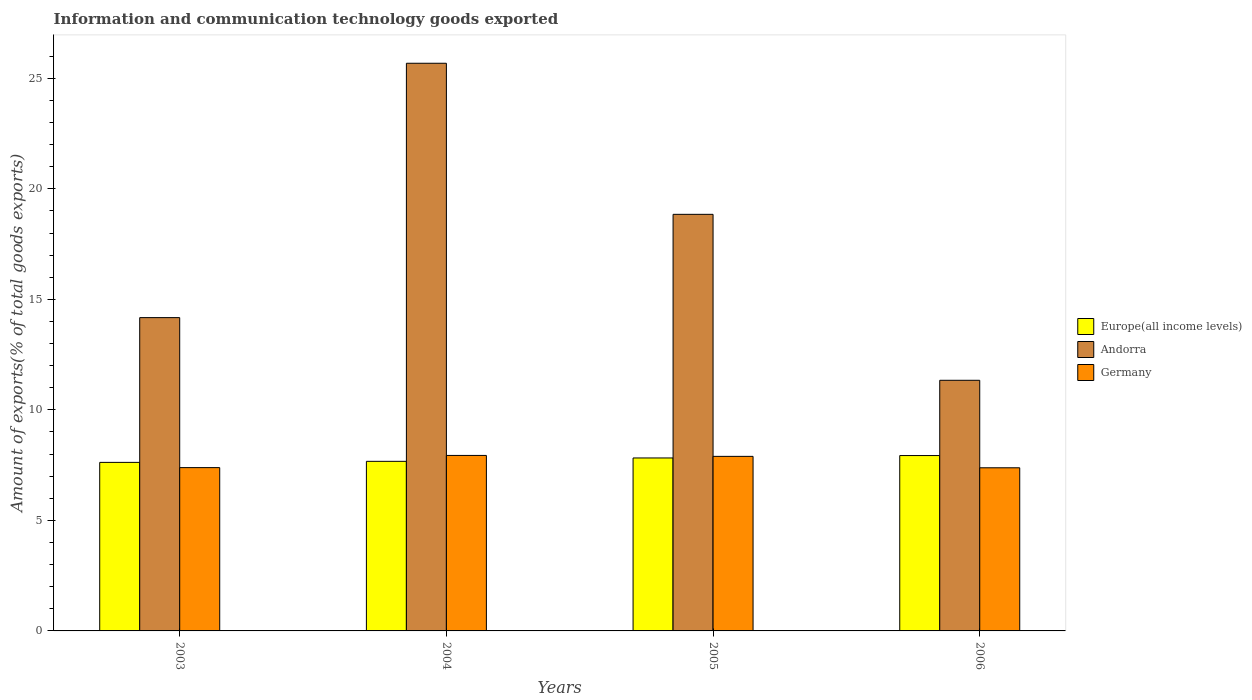How many different coloured bars are there?
Your response must be concise. 3. Are the number of bars on each tick of the X-axis equal?
Your answer should be very brief. Yes. How many bars are there on the 1st tick from the right?
Your answer should be compact. 3. What is the label of the 2nd group of bars from the left?
Keep it short and to the point. 2004. In how many cases, is the number of bars for a given year not equal to the number of legend labels?
Provide a short and direct response. 0. What is the amount of goods exported in Germany in 2006?
Ensure brevity in your answer.  7.38. Across all years, what is the maximum amount of goods exported in Europe(all income levels)?
Make the answer very short. 7.93. Across all years, what is the minimum amount of goods exported in Andorra?
Your answer should be very brief. 11.34. In which year was the amount of goods exported in Andorra minimum?
Ensure brevity in your answer.  2006. What is the total amount of goods exported in Germany in the graph?
Offer a terse response. 30.61. What is the difference between the amount of goods exported in Germany in 2003 and that in 2006?
Your answer should be very brief. 0.01. What is the difference between the amount of goods exported in Europe(all income levels) in 2003 and the amount of goods exported in Germany in 2005?
Offer a very short reply. -0.27. What is the average amount of goods exported in Germany per year?
Your answer should be very brief. 7.65. In the year 2005, what is the difference between the amount of goods exported in Andorra and amount of goods exported in Europe(all income levels)?
Your response must be concise. 11.02. What is the ratio of the amount of goods exported in Germany in 2003 to that in 2006?
Keep it short and to the point. 1. What is the difference between the highest and the second highest amount of goods exported in Europe(all income levels)?
Make the answer very short. 0.11. What is the difference between the highest and the lowest amount of goods exported in Germany?
Your response must be concise. 0.56. Is the sum of the amount of goods exported in Germany in 2003 and 2004 greater than the maximum amount of goods exported in Europe(all income levels) across all years?
Offer a terse response. Yes. What does the 2nd bar from the left in 2006 represents?
Provide a short and direct response. Andorra. What does the 2nd bar from the right in 2006 represents?
Your response must be concise. Andorra. Is it the case that in every year, the sum of the amount of goods exported in Andorra and amount of goods exported in Germany is greater than the amount of goods exported in Europe(all income levels)?
Ensure brevity in your answer.  Yes. How many bars are there?
Your answer should be very brief. 12. Are all the bars in the graph horizontal?
Provide a short and direct response. No. Are the values on the major ticks of Y-axis written in scientific E-notation?
Ensure brevity in your answer.  No. How many legend labels are there?
Offer a very short reply. 3. What is the title of the graph?
Make the answer very short. Information and communication technology goods exported. What is the label or title of the Y-axis?
Provide a succinct answer. Amount of exports(% of total goods exports). What is the Amount of exports(% of total goods exports) of Europe(all income levels) in 2003?
Offer a terse response. 7.63. What is the Amount of exports(% of total goods exports) in Andorra in 2003?
Give a very brief answer. 14.17. What is the Amount of exports(% of total goods exports) in Germany in 2003?
Make the answer very short. 7.39. What is the Amount of exports(% of total goods exports) of Europe(all income levels) in 2004?
Offer a terse response. 7.67. What is the Amount of exports(% of total goods exports) of Andorra in 2004?
Give a very brief answer. 25.68. What is the Amount of exports(% of total goods exports) of Germany in 2004?
Your answer should be compact. 7.94. What is the Amount of exports(% of total goods exports) in Europe(all income levels) in 2005?
Your answer should be very brief. 7.83. What is the Amount of exports(% of total goods exports) in Andorra in 2005?
Keep it short and to the point. 18.85. What is the Amount of exports(% of total goods exports) in Germany in 2005?
Provide a short and direct response. 7.9. What is the Amount of exports(% of total goods exports) in Europe(all income levels) in 2006?
Your answer should be very brief. 7.93. What is the Amount of exports(% of total goods exports) in Andorra in 2006?
Offer a very short reply. 11.34. What is the Amount of exports(% of total goods exports) in Germany in 2006?
Provide a succinct answer. 7.38. Across all years, what is the maximum Amount of exports(% of total goods exports) in Europe(all income levels)?
Keep it short and to the point. 7.93. Across all years, what is the maximum Amount of exports(% of total goods exports) of Andorra?
Make the answer very short. 25.68. Across all years, what is the maximum Amount of exports(% of total goods exports) in Germany?
Provide a short and direct response. 7.94. Across all years, what is the minimum Amount of exports(% of total goods exports) of Europe(all income levels)?
Provide a short and direct response. 7.63. Across all years, what is the minimum Amount of exports(% of total goods exports) in Andorra?
Give a very brief answer. 11.34. Across all years, what is the minimum Amount of exports(% of total goods exports) of Germany?
Provide a succinct answer. 7.38. What is the total Amount of exports(% of total goods exports) of Europe(all income levels) in the graph?
Provide a succinct answer. 31.06. What is the total Amount of exports(% of total goods exports) of Andorra in the graph?
Provide a short and direct response. 70.04. What is the total Amount of exports(% of total goods exports) in Germany in the graph?
Provide a short and direct response. 30.61. What is the difference between the Amount of exports(% of total goods exports) of Europe(all income levels) in 2003 and that in 2004?
Provide a short and direct response. -0.05. What is the difference between the Amount of exports(% of total goods exports) of Andorra in 2003 and that in 2004?
Provide a succinct answer. -11.51. What is the difference between the Amount of exports(% of total goods exports) of Germany in 2003 and that in 2004?
Offer a very short reply. -0.55. What is the difference between the Amount of exports(% of total goods exports) in Andorra in 2003 and that in 2005?
Give a very brief answer. -4.67. What is the difference between the Amount of exports(% of total goods exports) in Germany in 2003 and that in 2005?
Keep it short and to the point. -0.51. What is the difference between the Amount of exports(% of total goods exports) in Europe(all income levels) in 2003 and that in 2006?
Provide a succinct answer. -0.31. What is the difference between the Amount of exports(% of total goods exports) in Andorra in 2003 and that in 2006?
Give a very brief answer. 2.84. What is the difference between the Amount of exports(% of total goods exports) of Germany in 2003 and that in 2006?
Give a very brief answer. 0.01. What is the difference between the Amount of exports(% of total goods exports) of Europe(all income levels) in 2004 and that in 2005?
Offer a very short reply. -0.15. What is the difference between the Amount of exports(% of total goods exports) in Andorra in 2004 and that in 2005?
Offer a very short reply. 6.83. What is the difference between the Amount of exports(% of total goods exports) of Germany in 2004 and that in 2005?
Your response must be concise. 0.04. What is the difference between the Amount of exports(% of total goods exports) of Europe(all income levels) in 2004 and that in 2006?
Offer a terse response. -0.26. What is the difference between the Amount of exports(% of total goods exports) in Andorra in 2004 and that in 2006?
Provide a succinct answer. 14.34. What is the difference between the Amount of exports(% of total goods exports) of Germany in 2004 and that in 2006?
Your response must be concise. 0.56. What is the difference between the Amount of exports(% of total goods exports) in Europe(all income levels) in 2005 and that in 2006?
Your answer should be very brief. -0.11. What is the difference between the Amount of exports(% of total goods exports) in Andorra in 2005 and that in 2006?
Your answer should be very brief. 7.51. What is the difference between the Amount of exports(% of total goods exports) of Germany in 2005 and that in 2006?
Provide a short and direct response. 0.52. What is the difference between the Amount of exports(% of total goods exports) in Europe(all income levels) in 2003 and the Amount of exports(% of total goods exports) in Andorra in 2004?
Your answer should be very brief. -18.06. What is the difference between the Amount of exports(% of total goods exports) in Europe(all income levels) in 2003 and the Amount of exports(% of total goods exports) in Germany in 2004?
Keep it short and to the point. -0.31. What is the difference between the Amount of exports(% of total goods exports) in Andorra in 2003 and the Amount of exports(% of total goods exports) in Germany in 2004?
Ensure brevity in your answer.  6.23. What is the difference between the Amount of exports(% of total goods exports) in Europe(all income levels) in 2003 and the Amount of exports(% of total goods exports) in Andorra in 2005?
Offer a very short reply. -11.22. What is the difference between the Amount of exports(% of total goods exports) in Europe(all income levels) in 2003 and the Amount of exports(% of total goods exports) in Germany in 2005?
Provide a short and direct response. -0.27. What is the difference between the Amount of exports(% of total goods exports) of Andorra in 2003 and the Amount of exports(% of total goods exports) of Germany in 2005?
Offer a terse response. 6.28. What is the difference between the Amount of exports(% of total goods exports) in Europe(all income levels) in 2003 and the Amount of exports(% of total goods exports) in Andorra in 2006?
Your answer should be compact. -3.71. What is the difference between the Amount of exports(% of total goods exports) of Europe(all income levels) in 2003 and the Amount of exports(% of total goods exports) of Germany in 2006?
Ensure brevity in your answer.  0.24. What is the difference between the Amount of exports(% of total goods exports) in Andorra in 2003 and the Amount of exports(% of total goods exports) in Germany in 2006?
Your answer should be compact. 6.79. What is the difference between the Amount of exports(% of total goods exports) of Europe(all income levels) in 2004 and the Amount of exports(% of total goods exports) of Andorra in 2005?
Make the answer very short. -11.18. What is the difference between the Amount of exports(% of total goods exports) of Europe(all income levels) in 2004 and the Amount of exports(% of total goods exports) of Germany in 2005?
Your response must be concise. -0.23. What is the difference between the Amount of exports(% of total goods exports) of Andorra in 2004 and the Amount of exports(% of total goods exports) of Germany in 2005?
Your answer should be very brief. 17.79. What is the difference between the Amount of exports(% of total goods exports) of Europe(all income levels) in 2004 and the Amount of exports(% of total goods exports) of Andorra in 2006?
Make the answer very short. -3.67. What is the difference between the Amount of exports(% of total goods exports) in Europe(all income levels) in 2004 and the Amount of exports(% of total goods exports) in Germany in 2006?
Ensure brevity in your answer.  0.29. What is the difference between the Amount of exports(% of total goods exports) of Andorra in 2004 and the Amount of exports(% of total goods exports) of Germany in 2006?
Your answer should be very brief. 18.3. What is the difference between the Amount of exports(% of total goods exports) of Europe(all income levels) in 2005 and the Amount of exports(% of total goods exports) of Andorra in 2006?
Your answer should be very brief. -3.51. What is the difference between the Amount of exports(% of total goods exports) of Europe(all income levels) in 2005 and the Amount of exports(% of total goods exports) of Germany in 2006?
Offer a terse response. 0.44. What is the difference between the Amount of exports(% of total goods exports) in Andorra in 2005 and the Amount of exports(% of total goods exports) in Germany in 2006?
Provide a succinct answer. 11.47. What is the average Amount of exports(% of total goods exports) in Europe(all income levels) per year?
Make the answer very short. 7.76. What is the average Amount of exports(% of total goods exports) in Andorra per year?
Your answer should be compact. 17.51. What is the average Amount of exports(% of total goods exports) in Germany per year?
Offer a very short reply. 7.65. In the year 2003, what is the difference between the Amount of exports(% of total goods exports) of Europe(all income levels) and Amount of exports(% of total goods exports) of Andorra?
Keep it short and to the point. -6.55. In the year 2003, what is the difference between the Amount of exports(% of total goods exports) of Europe(all income levels) and Amount of exports(% of total goods exports) of Germany?
Provide a short and direct response. 0.24. In the year 2003, what is the difference between the Amount of exports(% of total goods exports) in Andorra and Amount of exports(% of total goods exports) in Germany?
Offer a very short reply. 6.79. In the year 2004, what is the difference between the Amount of exports(% of total goods exports) in Europe(all income levels) and Amount of exports(% of total goods exports) in Andorra?
Your answer should be compact. -18.01. In the year 2004, what is the difference between the Amount of exports(% of total goods exports) of Europe(all income levels) and Amount of exports(% of total goods exports) of Germany?
Your response must be concise. -0.27. In the year 2004, what is the difference between the Amount of exports(% of total goods exports) in Andorra and Amount of exports(% of total goods exports) in Germany?
Make the answer very short. 17.74. In the year 2005, what is the difference between the Amount of exports(% of total goods exports) of Europe(all income levels) and Amount of exports(% of total goods exports) of Andorra?
Offer a terse response. -11.02. In the year 2005, what is the difference between the Amount of exports(% of total goods exports) of Europe(all income levels) and Amount of exports(% of total goods exports) of Germany?
Your answer should be compact. -0.07. In the year 2005, what is the difference between the Amount of exports(% of total goods exports) in Andorra and Amount of exports(% of total goods exports) in Germany?
Ensure brevity in your answer.  10.95. In the year 2006, what is the difference between the Amount of exports(% of total goods exports) of Europe(all income levels) and Amount of exports(% of total goods exports) of Andorra?
Provide a succinct answer. -3.4. In the year 2006, what is the difference between the Amount of exports(% of total goods exports) in Europe(all income levels) and Amount of exports(% of total goods exports) in Germany?
Your answer should be compact. 0.55. In the year 2006, what is the difference between the Amount of exports(% of total goods exports) of Andorra and Amount of exports(% of total goods exports) of Germany?
Ensure brevity in your answer.  3.96. What is the ratio of the Amount of exports(% of total goods exports) of Europe(all income levels) in 2003 to that in 2004?
Ensure brevity in your answer.  0.99. What is the ratio of the Amount of exports(% of total goods exports) in Andorra in 2003 to that in 2004?
Offer a very short reply. 0.55. What is the ratio of the Amount of exports(% of total goods exports) of Germany in 2003 to that in 2004?
Offer a terse response. 0.93. What is the ratio of the Amount of exports(% of total goods exports) of Europe(all income levels) in 2003 to that in 2005?
Ensure brevity in your answer.  0.97. What is the ratio of the Amount of exports(% of total goods exports) in Andorra in 2003 to that in 2005?
Provide a short and direct response. 0.75. What is the ratio of the Amount of exports(% of total goods exports) in Germany in 2003 to that in 2005?
Ensure brevity in your answer.  0.94. What is the ratio of the Amount of exports(% of total goods exports) of Europe(all income levels) in 2003 to that in 2006?
Your answer should be very brief. 0.96. What is the ratio of the Amount of exports(% of total goods exports) in Germany in 2003 to that in 2006?
Make the answer very short. 1. What is the ratio of the Amount of exports(% of total goods exports) in Europe(all income levels) in 2004 to that in 2005?
Provide a short and direct response. 0.98. What is the ratio of the Amount of exports(% of total goods exports) of Andorra in 2004 to that in 2005?
Ensure brevity in your answer.  1.36. What is the ratio of the Amount of exports(% of total goods exports) in Europe(all income levels) in 2004 to that in 2006?
Give a very brief answer. 0.97. What is the ratio of the Amount of exports(% of total goods exports) in Andorra in 2004 to that in 2006?
Ensure brevity in your answer.  2.26. What is the ratio of the Amount of exports(% of total goods exports) in Germany in 2004 to that in 2006?
Your answer should be very brief. 1.08. What is the ratio of the Amount of exports(% of total goods exports) of Europe(all income levels) in 2005 to that in 2006?
Offer a terse response. 0.99. What is the ratio of the Amount of exports(% of total goods exports) of Andorra in 2005 to that in 2006?
Make the answer very short. 1.66. What is the ratio of the Amount of exports(% of total goods exports) in Germany in 2005 to that in 2006?
Provide a short and direct response. 1.07. What is the difference between the highest and the second highest Amount of exports(% of total goods exports) in Europe(all income levels)?
Ensure brevity in your answer.  0.11. What is the difference between the highest and the second highest Amount of exports(% of total goods exports) of Andorra?
Your answer should be compact. 6.83. What is the difference between the highest and the second highest Amount of exports(% of total goods exports) of Germany?
Your answer should be compact. 0.04. What is the difference between the highest and the lowest Amount of exports(% of total goods exports) in Europe(all income levels)?
Keep it short and to the point. 0.31. What is the difference between the highest and the lowest Amount of exports(% of total goods exports) in Andorra?
Your response must be concise. 14.34. What is the difference between the highest and the lowest Amount of exports(% of total goods exports) of Germany?
Ensure brevity in your answer.  0.56. 